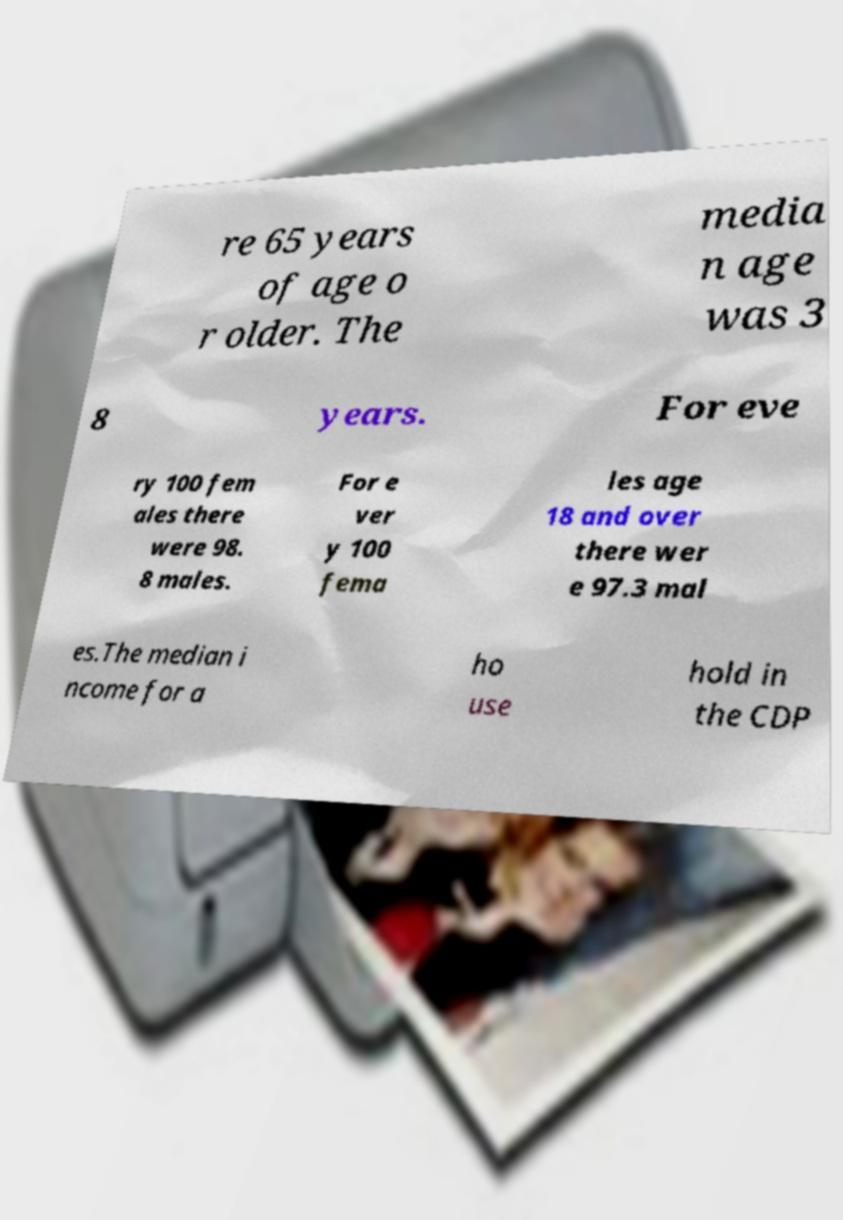Please read and relay the text visible in this image. What does it say? re 65 years of age o r older. The media n age was 3 8 years. For eve ry 100 fem ales there were 98. 8 males. For e ver y 100 fema les age 18 and over there wer e 97.3 mal es.The median i ncome for a ho use hold in the CDP 